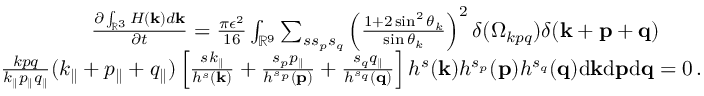Convert formula to latex. <formula><loc_0><loc_0><loc_500><loc_500>\begin{array} { r l r } & { \frac { \partial \int _ { { \mathbb { R } } ^ { 3 } } H ( { k } ) d { k } } { \partial t } = \frac { \pi \epsilon ^ { 2 } } { 1 6 } \int _ { { \mathbb { R } } ^ { 9 } } \sum _ { s s _ { p } s _ { q } } \left ( \frac { 1 + 2 \sin ^ { 2 } \theta _ { k } } { \sin \theta _ { k } } \right ) ^ { 2 } \delta ( \Omega _ { k p q } ) \delta ( { k } + { p } + { q } ) \quad } \\ & { \frac { k p q } { k _ { \| } p _ { \| } q _ { \| } } ( k _ { \| } + p _ { \| } + q _ { \| } ) \left [ \frac { s k _ { \| } } { h ^ { s } ( { k } ) } + \frac { s _ { p } p _ { \| } } { h ^ { s _ { p } } ( { p } ) } + \frac { s _ { q } q _ { \| } } { h ^ { s _ { q } } ( { q } ) } \right ] h ^ { s } ( { k } ) h ^ { s _ { p } } ( { p } ) h ^ { s _ { q } } ( { q } ) d { k } d { p } d { q } = 0 \, . } \end{array}</formula> 